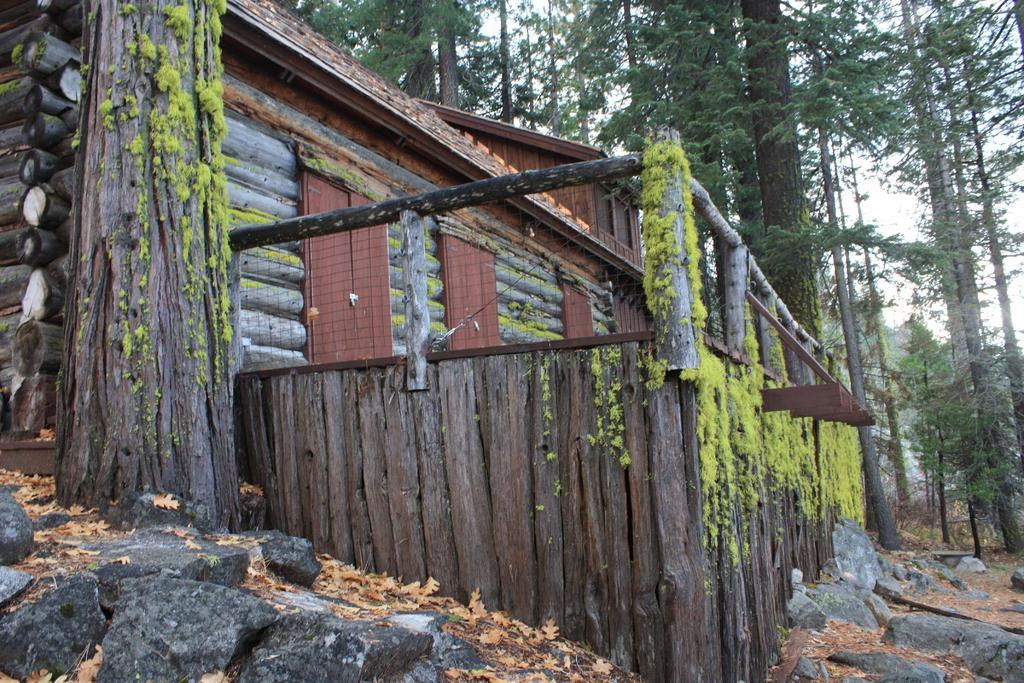How would you summarize this image in a sentence or two? In this image I can see few trees, few stones and dry leaves. I can see the wooden log house, doors and fencing. The sky is in white color. 